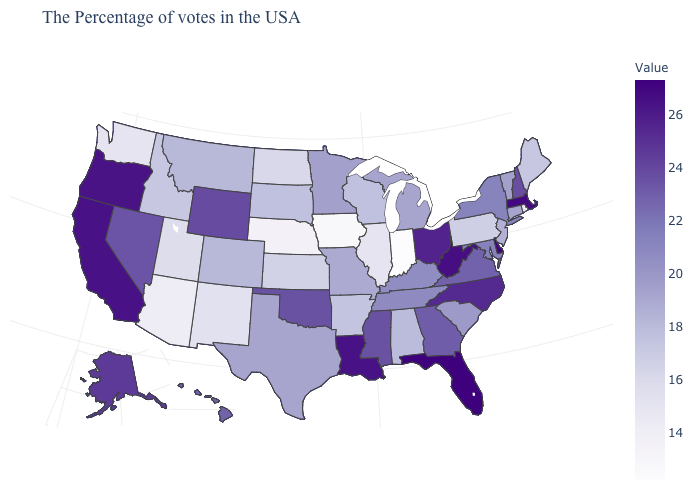Which states hav the highest value in the MidWest?
Concise answer only. Ohio. Does California have the highest value in the West?
Give a very brief answer. Yes. Is the legend a continuous bar?
Answer briefly. Yes. Among the states that border Oklahoma , which have the lowest value?
Write a very short answer. New Mexico. 